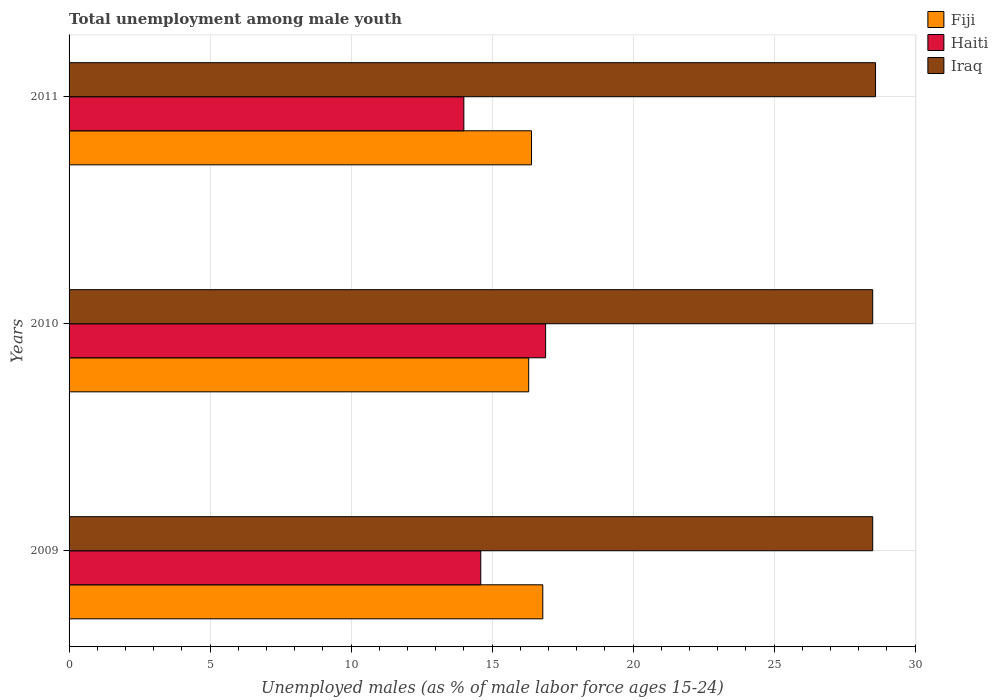How many different coloured bars are there?
Make the answer very short. 3. How many groups of bars are there?
Offer a very short reply. 3. Are the number of bars per tick equal to the number of legend labels?
Your answer should be compact. Yes. Are the number of bars on each tick of the Y-axis equal?
Make the answer very short. Yes. How many bars are there on the 1st tick from the bottom?
Offer a very short reply. 3. What is the label of the 2nd group of bars from the top?
Your answer should be compact. 2010. In how many cases, is the number of bars for a given year not equal to the number of legend labels?
Your answer should be compact. 0. What is the percentage of unemployed males in in Iraq in 2010?
Provide a succinct answer. 28.5. Across all years, what is the maximum percentage of unemployed males in in Iraq?
Ensure brevity in your answer.  28.6. In which year was the percentage of unemployed males in in Haiti maximum?
Offer a terse response. 2010. In which year was the percentage of unemployed males in in Iraq minimum?
Keep it short and to the point. 2009. What is the total percentage of unemployed males in in Haiti in the graph?
Keep it short and to the point. 45.5. What is the difference between the percentage of unemployed males in in Haiti in 2009 and that in 2010?
Give a very brief answer. -2.3. What is the difference between the percentage of unemployed males in in Haiti in 2009 and the percentage of unemployed males in in Iraq in 2011?
Your response must be concise. -14. What is the average percentage of unemployed males in in Fiji per year?
Provide a short and direct response. 16.5. In the year 2010, what is the difference between the percentage of unemployed males in in Iraq and percentage of unemployed males in in Fiji?
Keep it short and to the point. 12.2. What is the ratio of the percentage of unemployed males in in Haiti in 2010 to that in 2011?
Offer a terse response. 1.21. What is the difference between the highest and the second highest percentage of unemployed males in in Fiji?
Ensure brevity in your answer.  0.4. What is the difference between the highest and the lowest percentage of unemployed males in in Haiti?
Your answer should be very brief. 2.9. What does the 2nd bar from the top in 2011 represents?
Your answer should be compact. Haiti. What does the 2nd bar from the bottom in 2010 represents?
Provide a succinct answer. Haiti. Is it the case that in every year, the sum of the percentage of unemployed males in in Iraq and percentage of unemployed males in in Haiti is greater than the percentage of unemployed males in in Fiji?
Provide a succinct answer. Yes. How many bars are there?
Your answer should be compact. 9. Are all the bars in the graph horizontal?
Offer a very short reply. Yes. What is the difference between two consecutive major ticks on the X-axis?
Offer a very short reply. 5. Are the values on the major ticks of X-axis written in scientific E-notation?
Provide a short and direct response. No. Where does the legend appear in the graph?
Make the answer very short. Top right. How many legend labels are there?
Your response must be concise. 3. What is the title of the graph?
Your response must be concise. Total unemployment among male youth. What is the label or title of the X-axis?
Ensure brevity in your answer.  Unemployed males (as % of male labor force ages 15-24). What is the label or title of the Y-axis?
Offer a terse response. Years. What is the Unemployed males (as % of male labor force ages 15-24) in Fiji in 2009?
Make the answer very short. 16.8. What is the Unemployed males (as % of male labor force ages 15-24) in Haiti in 2009?
Your response must be concise. 14.6. What is the Unemployed males (as % of male labor force ages 15-24) in Fiji in 2010?
Provide a succinct answer. 16.3. What is the Unemployed males (as % of male labor force ages 15-24) of Haiti in 2010?
Your answer should be compact. 16.9. What is the Unemployed males (as % of male labor force ages 15-24) of Fiji in 2011?
Your response must be concise. 16.4. What is the Unemployed males (as % of male labor force ages 15-24) in Iraq in 2011?
Offer a very short reply. 28.6. Across all years, what is the maximum Unemployed males (as % of male labor force ages 15-24) of Fiji?
Your answer should be very brief. 16.8. Across all years, what is the maximum Unemployed males (as % of male labor force ages 15-24) in Haiti?
Offer a very short reply. 16.9. Across all years, what is the maximum Unemployed males (as % of male labor force ages 15-24) in Iraq?
Your answer should be very brief. 28.6. Across all years, what is the minimum Unemployed males (as % of male labor force ages 15-24) in Fiji?
Make the answer very short. 16.3. Across all years, what is the minimum Unemployed males (as % of male labor force ages 15-24) of Haiti?
Give a very brief answer. 14. What is the total Unemployed males (as % of male labor force ages 15-24) in Fiji in the graph?
Give a very brief answer. 49.5. What is the total Unemployed males (as % of male labor force ages 15-24) in Haiti in the graph?
Provide a short and direct response. 45.5. What is the total Unemployed males (as % of male labor force ages 15-24) in Iraq in the graph?
Your answer should be compact. 85.6. What is the difference between the Unemployed males (as % of male labor force ages 15-24) of Fiji in 2009 and that in 2010?
Give a very brief answer. 0.5. What is the difference between the Unemployed males (as % of male labor force ages 15-24) of Haiti in 2009 and that in 2010?
Your response must be concise. -2.3. What is the difference between the Unemployed males (as % of male labor force ages 15-24) of Iraq in 2009 and that in 2010?
Offer a very short reply. 0. What is the difference between the Unemployed males (as % of male labor force ages 15-24) in Fiji in 2009 and that in 2011?
Your answer should be compact. 0.4. What is the difference between the Unemployed males (as % of male labor force ages 15-24) in Haiti in 2009 and that in 2011?
Provide a succinct answer. 0.6. What is the difference between the Unemployed males (as % of male labor force ages 15-24) in Fiji in 2010 and that in 2011?
Keep it short and to the point. -0.1. What is the difference between the Unemployed males (as % of male labor force ages 15-24) in Iraq in 2010 and that in 2011?
Offer a very short reply. -0.1. What is the difference between the Unemployed males (as % of male labor force ages 15-24) in Fiji in 2009 and the Unemployed males (as % of male labor force ages 15-24) in Haiti in 2010?
Offer a very short reply. -0.1. What is the difference between the Unemployed males (as % of male labor force ages 15-24) in Fiji in 2009 and the Unemployed males (as % of male labor force ages 15-24) in Iraq in 2010?
Your answer should be very brief. -11.7. What is the difference between the Unemployed males (as % of male labor force ages 15-24) of Fiji in 2009 and the Unemployed males (as % of male labor force ages 15-24) of Haiti in 2011?
Provide a short and direct response. 2.8. What is the difference between the Unemployed males (as % of male labor force ages 15-24) of Fiji in 2009 and the Unemployed males (as % of male labor force ages 15-24) of Iraq in 2011?
Provide a succinct answer. -11.8. What is the difference between the Unemployed males (as % of male labor force ages 15-24) in Haiti in 2009 and the Unemployed males (as % of male labor force ages 15-24) in Iraq in 2011?
Offer a terse response. -14. What is the difference between the Unemployed males (as % of male labor force ages 15-24) in Fiji in 2010 and the Unemployed males (as % of male labor force ages 15-24) in Haiti in 2011?
Your answer should be compact. 2.3. What is the average Unemployed males (as % of male labor force ages 15-24) of Haiti per year?
Offer a terse response. 15.17. What is the average Unemployed males (as % of male labor force ages 15-24) of Iraq per year?
Your answer should be very brief. 28.53. In the year 2009, what is the difference between the Unemployed males (as % of male labor force ages 15-24) in Fiji and Unemployed males (as % of male labor force ages 15-24) in Iraq?
Provide a succinct answer. -11.7. In the year 2009, what is the difference between the Unemployed males (as % of male labor force ages 15-24) of Haiti and Unemployed males (as % of male labor force ages 15-24) of Iraq?
Ensure brevity in your answer.  -13.9. In the year 2010, what is the difference between the Unemployed males (as % of male labor force ages 15-24) in Haiti and Unemployed males (as % of male labor force ages 15-24) in Iraq?
Keep it short and to the point. -11.6. In the year 2011, what is the difference between the Unemployed males (as % of male labor force ages 15-24) of Haiti and Unemployed males (as % of male labor force ages 15-24) of Iraq?
Give a very brief answer. -14.6. What is the ratio of the Unemployed males (as % of male labor force ages 15-24) in Fiji in 2009 to that in 2010?
Offer a terse response. 1.03. What is the ratio of the Unemployed males (as % of male labor force ages 15-24) in Haiti in 2009 to that in 2010?
Give a very brief answer. 0.86. What is the ratio of the Unemployed males (as % of male labor force ages 15-24) in Iraq in 2009 to that in 2010?
Your answer should be very brief. 1. What is the ratio of the Unemployed males (as % of male labor force ages 15-24) of Fiji in 2009 to that in 2011?
Your answer should be compact. 1.02. What is the ratio of the Unemployed males (as % of male labor force ages 15-24) in Haiti in 2009 to that in 2011?
Offer a very short reply. 1.04. What is the ratio of the Unemployed males (as % of male labor force ages 15-24) of Haiti in 2010 to that in 2011?
Offer a very short reply. 1.21. What is the ratio of the Unemployed males (as % of male labor force ages 15-24) of Iraq in 2010 to that in 2011?
Offer a very short reply. 1. What is the difference between the highest and the second highest Unemployed males (as % of male labor force ages 15-24) of Fiji?
Your answer should be very brief. 0.4. What is the difference between the highest and the second highest Unemployed males (as % of male labor force ages 15-24) in Haiti?
Ensure brevity in your answer.  2.3. What is the difference between the highest and the lowest Unemployed males (as % of male labor force ages 15-24) of Haiti?
Give a very brief answer. 2.9. 